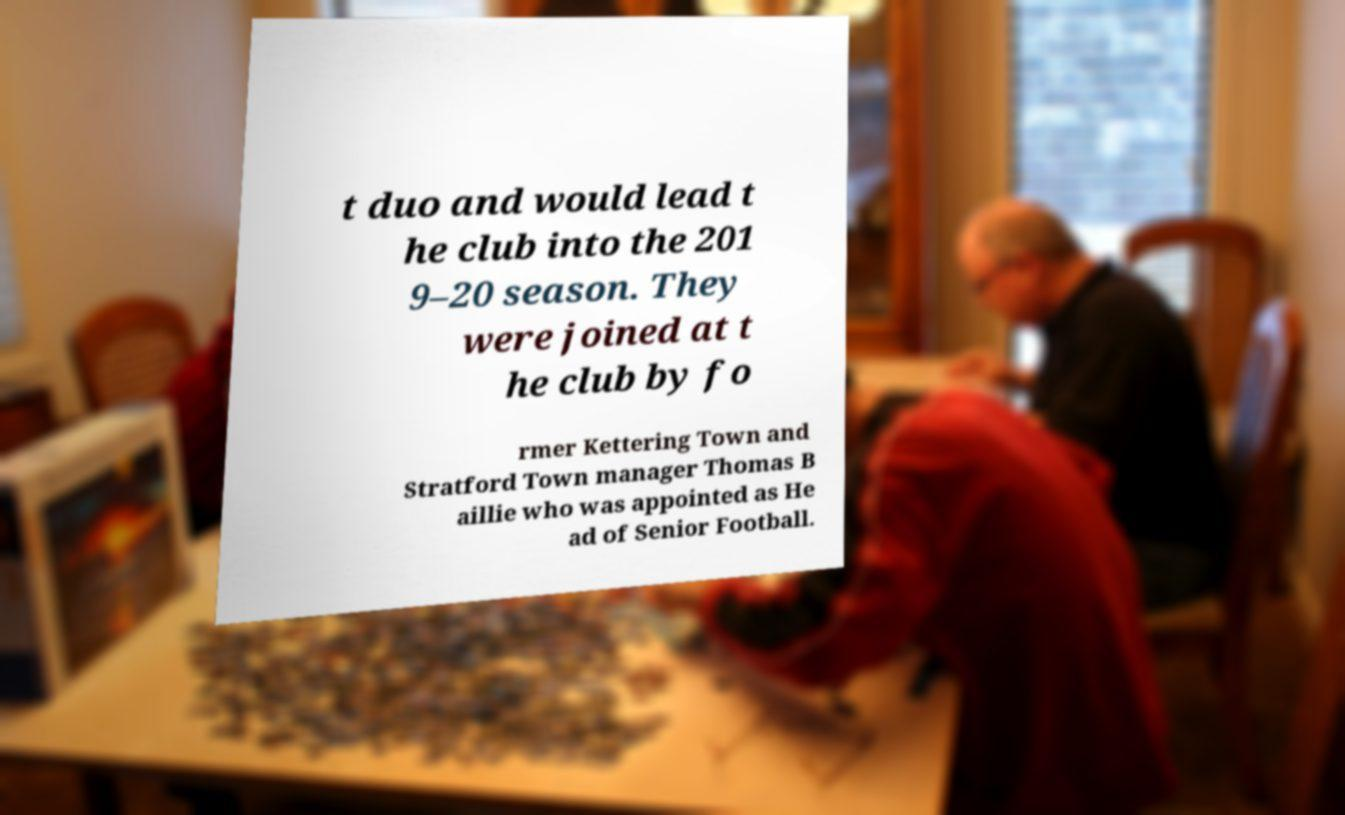There's text embedded in this image that I need extracted. Can you transcribe it verbatim? t duo and would lead t he club into the 201 9–20 season. They were joined at t he club by fo rmer Kettering Town and Stratford Town manager Thomas B aillie who was appointed as He ad of Senior Football. 